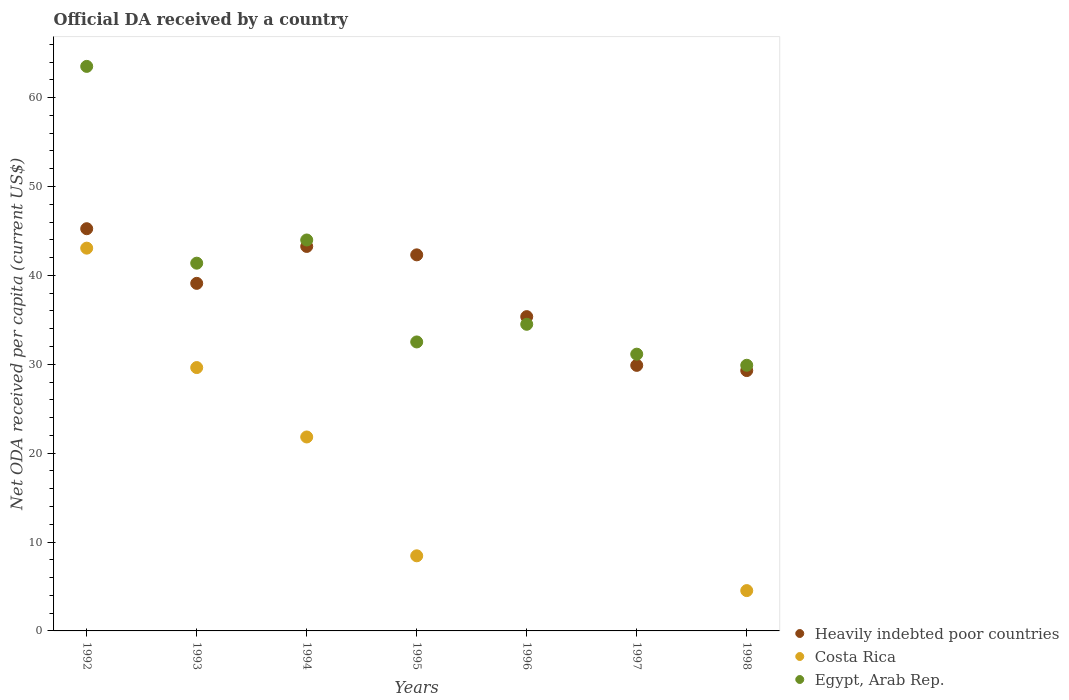Is the number of dotlines equal to the number of legend labels?
Offer a terse response. No. What is the ODA received in in Costa Rica in 1995?
Offer a very short reply. 8.45. Across all years, what is the maximum ODA received in in Heavily indebted poor countries?
Give a very brief answer. 45.25. Across all years, what is the minimum ODA received in in Heavily indebted poor countries?
Keep it short and to the point. 29.29. In which year was the ODA received in in Egypt, Arab Rep. maximum?
Keep it short and to the point. 1992. What is the total ODA received in in Egypt, Arab Rep. in the graph?
Your answer should be compact. 276.91. What is the difference between the ODA received in in Heavily indebted poor countries in 1993 and that in 1998?
Offer a terse response. 9.81. What is the difference between the ODA received in in Egypt, Arab Rep. in 1998 and the ODA received in in Costa Rica in 1995?
Ensure brevity in your answer.  21.44. What is the average ODA received in in Costa Rica per year?
Your response must be concise. 15.36. In the year 1998, what is the difference between the ODA received in in Costa Rica and ODA received in in Egypt, Arab Rep.?
Make the answer very short. -25.35. What is the ratio of the ODA received in in Egypt, Arab Rep. in 1992 to that in 1995?
Give a very brief answer. 1.95. Is the difference between the ODA received in in Costa Rica in 1994 and 1995 greater than the difference between the ODA received in in Egypt, Arab Rep. in 1994 and 1995?
Provide a succinct answer. Yes. What is the difference between the highest and the second highest ODA received in in Egypt, Arab Rep.?
Keep it short and to the point. 19.53. What is the difference between the highest and the lowest ODA received in in Costa Rica?
Give a very brief answer. 43.06. Is the sum of the ODA received in in Egypt, Arab Rep. in 1994 and 1996 greater than the maximum ODA received in in Heavily indebted poor countries across all years?
Keep it short and to the point. Yes. Does the ODA received in in Costa Rica monotonically increase over the years?
Make the answer very short. No. Is the ODA received in in Heavily indebted poor countries strictly less than the ODA received in in Egypt, Arab Rep. over the years?
Your response must be concise. No. How many dotlines are there?
Offer a very short reply. 3. How many years are there in the graph?
Offer a very short reply. 7. What is the difference between two consecutive major ticks on the Y-axis?
Offer a terse response. 10. Are the values on the major ticks of Y-axis written in scientific E-notation?
Offer a terse response. No. Does the graph contain grids?
Your answer should be compact. No. How are the legend labels stacked?
Ensure brevity in your answer.  Vertical. What is the title of the graph?
Your response must be concise. Official DA received by a country. What is the label or title of the X-axis?
Offer a very short reply. Years. What is the label or title of the Y-axis?
Ensure brevity in your answer.  Net ODA received per capita (current US$). What is the Net ODA received per capita (current US$) of Heavily indebted poor countries in 1992?
Your answer should be compact. 45.25. What is the Net ODA received per capita (current US$) in Costa Rica in 1992?
Offer a terse response. 43.06. What is the Net ODA received per capita (current US$) in Egypt, Arab Rep. in 1992?
Make the answer very short. 63.51. What is the Net ODA received per capita (current US$) of Heavily indebted poor countries in 1993?
Your answer should be compact. 39.1. What is the Net ODA received per capita (current US$) in Costa Rica in 1993?
Ensure brevity in your answer.  29.63. What is the Net ODA received per capita (current US$) of Egypt, Arab Rep. in 1993?
Your response must be concise. 41.37. What is the Net ODA received per capita (current US$) in Heavily indebted poor countries in 1994?
Offer a terse response. 43.26. What is the Net ODA received per capita (current US$) in Costa Rica in 1994?
Your answer should be compact. 21.82. What is the Net ODA received per capita (current US$) of Egypt, Arab Rep. in 1994?
Your answer should be very brief. 43.98. What is the Net ODA received per capita (current US$) in Heavily indebted poor countries in 1995?
Give a very brief answer. 42.31. What is the Net ODA received per capita (current US$) of Costa Rica in 1995?
Your response must be concise. 8.45. What is the Net ODA received per capita (current US$) of Egypt, Arab Rep. in 1995?
Provide a short and direct response. 32.51. What is the Net ODA received per capita (current US$) of Heavily indebted poor countries in 1996?
Provide a short and direct response. 35.36. What is the Net ODA received per capita (current US$) of Costa Rica in 1996?
Provide a short and direct response. 0. What is the Net ODA received per capita (current US$) in Egypt, Arab Rep. in 1996?
Provide a succinct answer. 34.5. What is the Net ODA received per capita (current US$) of Heavily indebted poor countries in 1997?
Keep it short and to the point. 29.88. What is the Net ODA received per capita (current US$) of Egypt, Arab Rep. in 1997?
Your answer should be very brief. 31.14. What is the Net ODA received per capita (current US$) in Heavily indebted poor countries in 1998?
Provide a succinct answer. 29.29. What is the Net ODA received per capita (current US$) in Costa Rica in 1998?
Give a very brief answer. 4.54. What is the Net ODA received per capita (current US$) of Egypt, Arab Rep. in 1998?
Provide a succinct answer. 29.89. Across all years, what is the maximum Net ODA received per capita (current US$) in Heavily indebted poor countries?
Keep it short and to the point. 45.25. Across all years, what is the maximum Net ODA received per capita (current US$) of Costa Rica?
Offer a terse response. 43.06. Across all years, what is the maximum Net ODA received per capita (current US$) in Egypt, Arab Rep.?
Give a very brief answer. 63.51. Across all years, what is the minimum Net ODA received per capita (current US$) of Heavily indebted poor countries?
Keep it short and to the point. 29.29. Across all years, what is the minimum Net ODA received per capita (current US$) of Egypt, Arab Rep.?
Provide a short and direct response. 29.89. What is the total Net ODA received per capita (current US$) of Heavily indebted poor countries in the graph?
Keep it short and to the point. 264.45. What is the total Net ODA received per capita (current US$) of Costa Rica in the graph?
Your answer should be compact. 107.5. What is the total Net ODA received per capita (current US$) of Egypt, Arab Rep. in the graph?
Offer a terse response. 276.91. What is the difference between the Net ODA received per capita (current US$) in Heavily indebted poor countries in 1992 and that in 1993?
Your response must be concise. 6.15. What is the difference between the Net ODA received per capita (current US$) of Costa Rica in 1992 and that in 1993?
Give a very brief answer. 13.44. What is the difference between the Net ODA received per capita (current US$) in Egypt, Arab Rep. in 1992 and that in 1993?
Your response must be concise. 22.14. What is the difference between the Net ODA received per capita (current US$) in Heavily indebted poor countries in 1992 and that in 1994?
Make the answer very short. 1.99. What is the difference between the Net ODA received per capita (current US$) of Costa Rica in 1992 and that in 1994?
Your response must be concise. 21.24. What is the difference between the Net ODA received per capita (current US$) in Egypt, Arab Rep. in 1992 and that in 1994?
Offer a terse response. 19.53. What is the difference between the Net ODA received per capita (current US$) of Heavily indebted poor countries in 1992 and that in 1995?
Your response must be concise. 2.94. What is the difference between the Net ODA received per capita (current US$) of Costa Rica in 1992 and that in 1995?
Ensure brevity in your answer.  34.61. What is the difference between the Net ODA received per capita (current US$) of Egypt, Arab Rep. in 1992 and that in 1995?
Your response must be concise. 31. What is the difference between the Net ODA received per capita (current US$) in Heavily indebted poor countries in 1992 and that in 1996?
Make the answer very short. 9.89. What is the difference between the Net ODA received per capita (current US$) of Egypt, Arab Rep. in 1992 and that in 1996?
Offer a very short reply. 29.02. What is the difference between the Net ODA received per capita (current US$) of Heavily indebted poor countries in 1992 and that in 1997?
Give a very brief answer. 15.38. What is the difference between the Net ODA received per capita (current US$) of Egypt, Arab Rep. in 1992 and that in 1997?
Provide a short and direct response. 32.38. What is the difference between the Net ODA received per capita (current US$) in Heavily indebted poor countries in 1992 and that in 1998?
Give a very brief answer. 15.96. What is the difference between the Net ODA received per capita (current US$) of Costa Rica in 1992 and that in 1998?
Make the answer very short. 38.53. What is the difference between the Net ODA received per capita (current US$) of Egypt, Arab Rep. in 1992 and that in 1998?
Give a very brief answer. 33.63. What is the difference between the Net ODA received per capita (current US$) of Heavily indebted poor countries in 1993 and that in 1994?
Ensure brevity in your answer.  -4.15. What is the difference between the Net ODA received per capita (current US$) of Costa Rica in 1993 and that in 1994?
Give a very brief answer. 7.81. What is the difference between the Net ODA received per capita (current US$) in Egypt, Arab Rep. in 1993 and that in 1994?
Provide a succinct answer. -2.61. What is the difference between the Net ODA received per capita (current US$) in Heavily indebted poor countries in 1993 and that in 1995?
Offer a terse response. -3.21. What is the difference between the Net ODA received per capita (current US$) in Costa Rica in 1993 and that in 1995?
Keep it short and to the point. 21.18. What is the difference between the Net ODA received per capita (current US$) in Egypt, Arab Rep. in 1993 and that in 1995?
Provide a short and direct response. 8.86. What is the difference between the Net ODA received per capita (current US$) in Heavily indebted poor countries in 1993 and that in 1996?
Make the answer very short. 3.74. What is the difference between the Net ODA received per capita (current US$) of Egypt, Arab Rep. in 1993 and that in 1996?
Offer a terse response. 6.88. What is the difference between the Net ODA received per capita (current US$) in Heavily indebted poor countries in 1993 and that in 1997?
Your answer should be very brief. 9.23. What is the difference between the Net ODA received per capita (current US$) of Egypt, Arab Rep. in 1993 and that in 1997?
Give a very brief answer. 10.24. What is the difference between the Net ODA received per capita (current US$) in Heavily indebted poor countries in 1993 and that in 1998?
Ensure brevity in your answer.  9.81. What is the difference between the Net ODA received per capita (current US$) in Costa Rica in 1993 and that in 1998?
Ensure brevity in your answer.  25.09. What is the difference between the Net ODA received per capita (current US$) of Egypt, Arab Rep. in 1993 and that in 1998?
Your response must be concise. 11.49. What is the difference between the Net ODA received per capita (current US$) of Heavily indebted poor countries in 1994 and that in 1995?
Make the answer very short. 0.95. What is the difference between the Net ODA received per capita (current US$) in Costa Rica in 1994 and that in 1995?
Offer a terse response. 13.37. What is the difference between the Net ODA received per capita (current US$) of Egypt, Arab Rep. in 1994 and that in 1995?
Provide a short and direct response. 11.47. What is the difference between the Net ODA received per capita (current US$) of Heavily indebted poor countries in 1994 and that in 1996?
Make the answer very short. 7.9. What is the difference between the Net ODA received per capita (current US$) of Egypt, Arab Rep. in 1994 and that in 1996?
Give a very brief answer. 9.48. What is the difference between the Net ODA received per capita (current US$) of Heavily indebted poor countries in 1994 and that in 1997?
Give a very brief answer. 13.38. What is the difference between the Net ODA received per capita (current US$) in Egypt, Arab Rep. in 1994 and that in 1997?
Your response must be concise. 12.84. What is the difference between the Net ODA received per capita (current US$) of Heavily indebted poor countries in 1994 and that in 1998?
Offer a very short reply. 13.97. What is the difference between the Net ODA received per capita (current US$) of Costa Rica in 1994 and that in 1998?
Your answer should be very brief. 17.28. What is the difference between the Net ODA received per capita (current US$) in Egypt, Arab Rep. in 1994 and that in 1998?
Your answer should be compact. 14.09. What is the difference between the Net ODA received per capita (current US$) of Heavily indebted poor countries in 1995 and that in 1996?
Ensure brevity in your answer.  6.95. What is the difference between the Net ODA received per capita (current US$) of Egypt, Arab Rep. in 1995 and that in 1996?
Your response must be concise. -1.99. What is the difference between the Net ODA received per capita (current US$) of Heavily indebted poor countries in 1995 and that in 1997?
Make the answer very short. 12.44. What is the difference between the Net ODA received per capita (current US$) in Egypt, Arab Rep. in 1995 and that in 1997?
Your answer should be compact. 1.37. What is the difference between the Net ODA received per capita (current US$) of Heavily indebted poor countries in 1995 and that in 1998?
Give a very brief answer. 13.02. What is the difference between the Net ODA received per capita (current US$) of Costa Rica in 1995 and that in 1998?
Offer a terse response. 3.91. What is the difference between the Net ODA received per capita (current US$) of Egypt, Arab Rep. in 1995 and that in 1998?
Provide a succinct answer. 2.62. What is the difference between the Net ODA received per capita (current US$) of Heavily indebted poor countries in 1996 and that in 1997?
Make the answer very short. 5.48. What is the difference between the Net ODA received per capita (current US$) in Egypt, Arab Rep. in 1996 and that in 1997?
Your answer should be compact. 3.36. What is the difference between the Net ODA received per capita (current US$) of Heavily indebted poor countries in 1996 and that in 1998?
Ensure brevity in your answer.  6.07. What is the difference between the Net ODA received per capita (current US$) of Egypt, Arab Rep. in 1996 and that in 1998?
Make the answer very short. 4.61. What is the difference between the Net ODA received per capita (current US$) in Heavily indebted poor countries in 1997 and that in 1998?
Make the answer very short. 0.58. What is the difference between the Net ODA received per capita (current US$) in Egypt, Arab Rep. in 1997 and that in 1998?
Make the answer very short. 1.25. What is the difference between the Net ODA received per capita (current US$) in Heavily indebted poor countries in 1992 and the Net ODA received per capita (current US$) in Costa Rica in 1993?
Make the answer very short. 15.62. What is the difference between the Net ODA received per capita (current US$) of Heavily indebted poor countries in 1992 and the Net ODA received per capita (current US$) of Egypt, Arab Rep. in 1993?
Give a very brief answer. 3.88. What is the difference between the Net ODA received per capita (current US$) of Costa Rica in 1992 and the Net ODA received per capita (current US$) of Egypt, Arab Rep. in 1993?
Provide a short and direct response. 1.69. What is the difference between the Net ODA received per capita (current US$) in Heavily indebted poor countries in 1992 and the Net ODA received per capita (current US$) in Costa Rica in 1994?
Ensure brevity in your answer.  23.43. What is the difference between the Net ODA received per capita (current US$) in Heavily indebted poor countries in 1992 and the Net ODA received per capita (current US$) in Egypt, Arab Rep. in 1994?
Provide a short and direct response. 1.27. What is the difference between the Net ODA received per capita (current US$) in Costa Rica in 1992 and the Net ODA received per capita (current US$) in Egypt, Arab Rep. in 1994?
Provide a short and direct response. -0.92. What is the difference between the Net ODA received per capita (current US$) of Heavily indebted poor countries in 1992 and the Net ODA received per capita (current US$) of Costa Rica in 1995?
Your answer should be very brief. 36.8. What is the difference between the Net ODA received per capita (current US$) of Heavily indebted poor countries in 1992 and the Net ODA received per capita (current US$) of Egypt, Arab Rep. in 1995?
Give a very brief answer. 12.74. What is the difference between the Net ODA received per capita (current US$) of Costa Rica in 1992 and the Net ODA received per capita (current US$) of Egypt, Arab Rep. in 1995?
Provide a succinct answer. 10.55. What is the difference between the Net ODA received per capita (current US$) of Heavily indebted poor countries in 1992 and the Net ODA received per capita (current US$) of Egypt, Arab Rep. in 1996?
Your response must be concise. 10.75. What is the difference between the Net ODA received per capita (current US$) in Costa Rica in 1992 and the Net ODA received per capita (current US$) in Egypt, Arab Rep. in 1996?
Keep it short and to the point. 8.57. What is the difference between the Net ODA received per capita (current US$) of Heavily indebted poor countries in 1992 and the Net ODA received per capita (current US$) of Egypt, Arab Rep. in 1997?
Give a very brief answer. 14.11. What is the difference between the Net ODA received per capita (current US$) of Costa Rica in 1992 and the Net ODA received per capita (current US$) of Egypt, Arab Rep. in 1997?
Your response must be concise. 11.93. What is the difference between the Net ODA received per capita (current US$) in Heavily indebted poor countries in 1992 and the Net ODA received per capita (current US$) in Costa Rica in 1998?
Keep it short and to the point. 40.72. What is the difference between the Net ODA received per capita (current US$) in Heavily indebted poor countries in 1992 and the Net ODA received per capita (current US$) in Egypt, Arab Rep. in 1998?
Offer a very short reply. 15.36. What is the difference between the Net ODA received per capita (current US$) in Costa Rica in 1992 and the Net ODA received per capita (current US$) in Egypt, Arab Rep. in 1998?
Keep it short and to the point. 13.18. What is the difference between the Net ODA received per capita (current US$) in Heavily indebted poor countries in 1993 and the Net ODA received per capita (current US$) in Costa Rica in 1994?
Provide a short and direct response. 17.28. What is the difference between the Net ODA received per capita (current US$) of Heavily indebted poor countries in 1993 and the Net ODA received per capita (current US$) of Egypt, Arab Rep. in 1994?
Your answer should be compact. -4.88. What is the difference between the Net ODA received per capita (current US$) of Costa Rica in 1993 and the Net ODA received per capita (current US$) of Egypt, Arab Rep. in 1994?
Your answer should be very brief. -14.35. What is the difference between the Net ODA received per capita (current US$) of Heavily indebted poor countries in 1993 and the Net ODA received per capita (current US$) of Costa Rica in 1995?
Give a very brief answer. 30.65. What is the difference between the Net ODA received per capita (current US$) of Heavily indebted poor countries in 1993 and the Net ODA received per capita (current US$) of Egypt, Arab Rep. in 1995?
Provide a succinct answer. 6.59. What is the difference between the Net ODA received per capita (current US$) in Costa Rica in 1993 and the Net ODA received per capita (current US$) in Egypt, Arab Rep. in 1995?
Your answer should be compact. -2.88. What is the difference between the Net ODA received per capita (current US$) of Heavily indebted poor countries in 1993 and the Net ODA received per capita (current US$) of Egypt, Arab Rep. in 1996?
Provide a short and direct response. 4.61. What is the difference between the Net ODA received per capita (current US$) in Costa Rica in 1993 and the Net ODA received per capita (current US$) in Egypt, Arab Rep. in 1996?
Provide a succinct answer. -4.87. What is the difference between the Net ODA received per capita (current US$) in Heavily indebted poor countries in 1993 and the Net ODA received per capita (current US$) in Egypt, Arab Rep. in 1997?
Keep it short and to the point. 7.97. What is the difference between the Net ODA received per capita (current US$) of Costa Rica in 1993 and the Net ODA received per capita (current US$) of Egypt, Arab Rep. in 1997?
Offer a terse response. -1.51. What is the difference between the Net ODA received per capita (current US$) in Heavily indebted poor countries in 1993 and the Net ODA received per capita (current US$) in Costa Rica in 1998?
Provide a short and direct response. 34.57. What is the difference between the Net ODA received per capita (current US$) of Heavily indebted poor countries in 1993 and the Net ODA received per capita (current US$) of Egypt, Arab Rep. in 1998?
Offer a very short reply. 9.22. What is the difference between the Net ODA received per capita (current US$) in Costa Rica in 1993 and the Net ODA received per capita (current US$) in Egypt, Arab Rep. in 1998?
Keep it short and to the point. -0.26. What is the difference between the Net ODA received per capita (current US$) of Heavily indebted poor countries in 1994 and the Net ODA received per capita (current US$) of Costa Rica in 1995?
Provide a short and direct response. 34.81. What is the difference between the Net ODA received per capita (current US$) of Heavily indebted poor countries in 1994 and the Net ODA received per capita (current US$) of Egypt, Arab Rep. in 1995?
Ensure brevity in your answer.  10.75. What is the difference between the Net ODA received per capita (current US$) of Costa Rica in 1994 and the Net ODA received per capita (current US$) of Egypt, Arab Rep. in 1995?
Provide a succinct answer. -10.69. What is the difference between the Net ODA received per capita (current US$) of Heavily indebted poor countries in 1994 and the Net ODA received per capita (current US$) of Egypt, Arab Rep. in 1996?
Offer a very short reply. 8.76. What is the difference between the Net ODA received per capita (current US$) in Costa Rica in 1994 and the Net ODA received per capita (current US$) in Egypt, Arab Rep. in 1996?
Ensure brevity in your answer.  -12.68. What is the difference between the Net ODA received per capita (current US$) in Heavily indebted poor countries in 1994 and the Net ODA received per capita (current US$) in Egypt, Arab Rep. in 1997?
Provide a short and direct response. 12.12. What is the difference between the Net ODA received per capita (current US$) in Costa Rica in 1994 and the Net ODA received per capita (current US$) in Egypt, Arab Rep. in 1997?
Offer a terse response. -9.32. What is the difference between the Net ODA received per capita (current US$) of Heavily indebted poor countries in 1994 and the Net ODA received per capita (current US$) of Costa Rica in 1998?
Give a very brief answer. 38.72. What is the difference between the Net ODA received per capita (current US$) of Heavily indebted poor countries in 1994 and the Net ODA received per capita (current US$) of Egypt, Arab Rep. in 1998?
Provide a succinct answer. 13.37. What is the difference between the Net ODA received per capita (current US$) in Costa Rica in 1994 and the Net ODA received per capita (current US$) in Egypt, Arab Rep. in 1998?
Keep it short and to the point. -8.07. What is the difference between the Net ODA received per capita (current US$) in Heavily indebted poor countries in 1995 and the Net ODA received per capita (current US$) in Egypt, Arab Rep. in 1996?
Offer a very short reply. 7.81. What is the difference between the Net ODA received per capita (current US$) in Costa Rica in 1995 and the Net ODA received per capita (current US$) in Egypt, Arab Rep. in 1996?
Your answer should be compact. -26.05. What is the difference between the Net ODA received per capita (current US$) in Heavily indebted poor countries in 1995 and the Net ODA received per capita (current US$) in Egypt, Arab Rep. in 1997?
Offer a terse response. 11.17. What is the difference between the Net ODA received per capita (current US$) of Costa Rica in 1995 and the Net ODA received per capita (current US$) of Egypt, Arab Rep. in 1997?
Your answer should be compact. -22.69. What is the difference between the Net ODA received per capita (current US$) in Heavily indebted poor countries in 1995 and the Net ODA received per capita (current US$) in Costa Rica in 1998?
Your response must be concise. 37.78. What is the difference between the Net ODA received per capita (current US$) of Heavily indebted poor countries in 1995 and the Net ODA received per capita (current US$) of Egypt, Arab Rep. in 1998?
Keep it short and to the point. 12.42. What is the difference between the Net ODA received per capita (current US$) in Costa Rica in 1995 and the Net ODA received per capita (current US$) in Egypt, Arab Rep. in 1998?
Your answer should be compact. -21.44. What is the difference between the Net ODA received per capita (current US$) in Heavily indebted poor countries in 1996 and the Net ODA received per capita (current US$) in Egypt, Arab Rep. in 1997?
Your answer should be compact. 4.22. What is the difference between the Net ODA received per capita (current US$) of Heavily indebted poor countries in 1996 and the Net ODA received per capita (current US$) of Costa Rica in 1998?
Offer a terse response. 30.82. What is the difference between the Net ODA received per capita (current US$) in Heavily indebted poor countries in 1996 and the Net ODA received per capita (current US$) in Egypt, Arab Rep. in 1998?
Give a very brief answer. 5.47. What is the difference between the Net ODA received per capita (current US$) of Heavily indebted poor countries in 1997 and the Net ODA received per capita (current US$) of Costa Rica in 1998?
Your answer should be very brief. 25.34. What is the difference between the Net ODA received per capita (current US$) of Heavily indebted poor countries in 1997 and the Net ODA received per capita (current US$) of Egypt, Arab Rep. in 1998?
Your response must be concise. -0.01. What is the average Net ODA received per capita (current US$) in Heavily indebted poor countries per year?
Give a very brief answer. 37.78. What is the average Net ODA received per capita (current US$) of Costa Rica per year?
Offer a terse response. 15.36. What is the average Net ODA received per capita (current US$) of Egypt, Arab Rep. per year?
Keep it short and to the point. 39.56. In the year 1992, what is the difference between the Net ODA received per capita (current US$) of Heavily indebted poor countries and Net ODA received per capita (current US$) of Costa Rica?
Provide a succinct answer. 2.19. In the year 1992, what is the difference between the Net ODA received per capita (current US$) of Heavily indebted poor countries and Net ODA received per capita (current US$) of Egypt, Arab Rep.?
Make the answer very short. -18.26. In the year 1992, what is the difference between the Net ODA received per capita (current US$) of Costa Rica and Net ODA received per capita (current US$) of Egypt, Arab Rep.?
Make the answer very short. -20.45. In the year 1993, what is the difference between the Net ODA received per capita (current US$) in Heavily indebted poor countries and Net ODA received per capita (current US$) in Costa Rica?
Offer a very short reply. 9.48. In the year 1993, what is the difference between the Net ODA received per capita (current US$) in Heavily indebted poor countries and Net ODA received per capita (current US$) in Egypt, Arab Rep.?
Offer a terse response. -2.27. In the year 1993, what is the difference between the Net ODA received per capita (current US$) in Costa Rica and Net ODA received per capita (current US$) in Egypt, Arab Rep.?
Your answer should be very brief. -11.75. In the year 1994, what is the difference between the Net ODA received per capita (current US$) in Heavily indebted poor countries and Net ODA received per capita (current US$) in Costa Rica?
Offer a very short reply. 21.44. In the year 1994, what is the difference between the Net ODA received per capita (current US$) in Heavily indebted poor countries and Net ODA received per capita (current US$) in Egypt, Arab Rep.?
Your response must be concise. -0.72. In the year 1994, what is the difference between the Net ODA received per capita (current US$) in Costa Rica and Net ODA received per capita (current US$) in Egypt, Arab Rep.?
Keep it short and to the point. -22.16. In the year 1995, what is the difference between the Net ODA received per capita (current US$) in Heavily indebted poor countries and Net ODA received per capita (current US$) in Costa Rica?
Keep it short and to the point. 33.86. In the year 1995, what is the difference between the Net ODA received per capita (current US$) in Heavily indebted poor countries and Net ODA received per capita (current US$) in Egypt, Arab Rep.?
Provide a succinct answer. 9.8. In the year 1995, what is the difference between the Net ODA received per capita (current US$) in Costa Rica and Net ODA received per capita (current US$) in Egypt, Arab Rep.?
Offer a very short reply. -24.06. In the year 1996, what is the difference between the Net ODA received per capita (current US$) of Heavily indebted poor countries and Net ODA received per capita (current US$) of Egypt, Arab Rep.?
Your answer should be compact. 0.86. In the year 1997, what is the difference between the Net ODA received per capita (current US$) of Heavily indebted poor countries and Net ODA received per capita (current US$) of Egypt, Arab Rep.?
Your response must be concise. -1.26. In the year 1998, what is the difference between the Net ODA received per capita (current US$) in Heavily indebted poor countries and Net ODA received per capita (current US$) in Costa Rica?
Give a very brief answer. 24.76. In the year 1998, what is the difference between the Net ODA received per capita (current US$) of Heavily indebted poor countries and Net ODA received per capita (current US$) of Egypt, Arab Rep.?
Your response must be concise. -0.6. In the year 1998, what is the difference between the Net ODA received per capita (current US$) in Costa Rica and Net ODA received per capita (current US$) in Egypt, Arab Rep.?
Provide a short and direct response. -25.35. What is the ratio of the Net ODA received per capita (current US$) in Heavily indebted poor countries in 1992 to that in 1993?
Make the answer very short. 1.16. What is the ratio of the Net ODA received per capita (current US$) of Costa Rica in 1992 to that in 1993?
Make the answer very short. 1.45. What is the ratio of the Net ODA received per capita (current US$) of Egypt, Arab Rep. in 1992 to that in 1993?
Offer a very short reply. 1.54. What is the ratio of the Net ODA received per capita (current US$) in Heavily indebted poor countries in 1992 to that in 1994?
Provide a short and direct response. 1.05. What is the ratio of the Net ODA received per capita (current US$) of Costa Rica in 1992 to that in 1994?
Provide a succinct answer. 1.97. What is the ratio of the Net ODA received per capita (current US$) of Egypt, Arab Rep. in 1992 to that in 1994?
Your response must be concise. 1.44. What is the ratio of the Net ODA received per capita (current US$) of Heavily indebted poor countries in 1992 to that in 1995?
Offer a very short reply. 1.07. What is the ratio of the Net ODA received per capita (current US$) of Costa Rica in 1992 to that in 1995?
Give a very brief answer. 5.1. What is the ratio of the Net ODA received per capita (current US$) in Egypt, Arab Rep. in 1992 to that in 1995?
Keep it short and to the point. 1.95. What is the ratio of the Net ODA received per capita (current US$) of Heavily indebted poor countries in 1992 to that in 1996?
Ensure brevity in your answer.  1.28. What is the ratio of the Net ODA received per capita (current US$) in Egypt, Arab Rep. in 1992 to that in 1996?
Give a very brief answer. 1.84. What is the ratio of the Net ODA received per capita (current US$) in Heavily indebted poor countries in 1992 to that in 1997?
Offer a very short reply. 1.51. What is the ratio of the Net ODA received per capita (current US$) of Egypt, Arab Rep. in 1992 to that in 1997?
Provide a short and direct response. 2.04. What is the ratio of the Net ODA received per capita (current US$) of Heavily indebted poor countries in 1992 to that in 1998?
Your answer should be very brief. 1.54. What is the ratio of the Net ODA received per capita (current US$) of Costa Rica in 1992 to that in 1998?
Your answer should be compact. 9.49. What is the ratio of the Net ODA received per capita (current US$) of Egypt, Arab Rep. in 1992 to that in 1998?
Ensure brevity in your answer.  2.13. What is the ratio of the Net ODA received per capita (current US$) in Heavily indebted poor countries in 1993 to that in 1994?
Offer a terse response. 0.9. What is the ratio of the Net ODA received per capita (current US$) of Costa Rica in 1993 to that in 1994?
Provide a short and direct response. 1.36. What is the ratio of the Net ODA received per capita (current US$) of Egypt, Arab Rep. in 1993 to that in 1994?
Your answer should be compact. 0.94. What is the ratio of the Net ODA received per capita (current US$) in Heavily indebted poor countries in 1993 to that in 1995?
Your answer should be very brief. 0.92. What is the ratio of the Net ODA received per capita (current US$) in Costa Rica in 1993 to that in 1995?
Give a very brief answer. 3.51. What is the ratio of the Net ODA received per capita (current US$) in Egypt, Arab Rep. in 1993 to that in 1995?
Provide a short and direct response. 1.27. What is the ratio of the Net ODA received per capita (current US$) in Heavily indebted poor countries in 1993 to that in 1996?
Give a very brief answer. 1.11. What is the ratio of the Net ODA received per capita (current US$) of Egypt, Arab Rep. in 1993 to that in 1996?
Ensure brevity in your answer.  1.2. What is the ratio of the Net ODA received per capita (current US$) in Heavily indebted poor countries in 1993 to that in 1997?
Keep it short and to the point. 1.31. What is the ratio of the Net ODA received per capita (current US$) of Egypt, Arab Rep. in 1993 to that in 1997?
Make the answer very short. 1.33. What is the ratio of the Net ODA received per capita (current US$) of Heavily indebted poor countries in 1993 to that in 1998?
Your response must be concise. 1.33. What is the ratio of the Net ODA received per capita (current US$) of Costa Rica in 1993 to that in 1998?
Keep it short and to the point. 6.53. What is the ratio of the Net ODA received per capita (current US$) of Egypt, Arab Rep. in 1993 to that in 1998?
Keep it short and to the point. 1.38. What is the ratio of the Net ODA received per capita (current US$) in Heavily indebted poor countries in 1994 to that in 1995?
Your answer should be compact. 1.02. What is the ratio of the Net ODA received per capita (current US$) of Costa Rica in 1994 to that in 1995?
Keep it short and to the point. 2.58. What is the ratio of the Net ODA received per capita (current US$) in Egypt, Arab Rep. in 1994 to that in 1995?
Offer a terse response. 1.35. What is the ratio of the Net ODA received per capita (current US$) of Heavily indebted poor countries in 1994 to that in 1996?
Ensure brevity in your answer.  1.22. What is the ratio of the Net ODA received per capita (current US$) in Egypt, Arab Rep. in 1994 to that in 1996?
Your response must be concise. 1.27. What is the ratio of the Net ODA received per capita (current US$) in Heavily indebted poor countries in 1994 to that in 1997?
Make the answer very short. 1.45. What is the ratio of the Net ODA received per capita (current US$) of Egypt, Arab Rep. in 1994 to that in 1997?
Give a very brief answer. 1.41. What is the ratio of the Net ODA received per capita (current US$) of Heavily indebted poor countries in 1994 to that in 1998?
Give a very brief answer. 1.48. What is the ratio of the Net ODA received per capita (current US$) in Costa Rica in 1994 to that in 1998?
Give a very brief answer. 4.81. What is the ratio of the Net ODA received per capita (current US$) of Egypt, Arab Rep. in 1994 to that in 1998?
Provide a short and direct response. 1.47. What is the ratio of the Net ODA received per capita (current US$) of Heavily indebted poor countries in 1995 to that in 1996?
Ensure brevity in your answer.  1.2. What is the ratio of the Net ODA received per capita (current US$) in Egypt, Arab Rep. in 1995 to that in 1996?
Ensure brevity in your answer.  0.94. What is the ratio of the Net ODA received per capita (current US$) of Heavily indebted poor countries in 1995 to that in 1997?
Your answer should be very brief. 1.42. What is the ratio of the Net ODA received per capita (current US$) in Egypt, Arab Rep. in 1995 to that in 1997?
Ensure brevity in your answer.  1.04. What is the ratio of the Net ODA received per capita (current US$) of Heavily indebted poor countries in 1995 to that in 1998?
Your answer should be compact. 1.44. What is the ratio of the Net ODA received per capita (current US$) in Costa Rica in 1995 to that in 1998?
Offer a terse response. 1.86. What is the ratio of the Net ODA received per capita (current US$) of Egypt, Arab Rep. in 1995 to that in 1998?
Keep it short and to the point. 1.09. What is the ratio of the Net ODA received per capita (current US$) in Heavily indebted poor countries in 1996 to that in 1997?
Your response must be concise. 1.18. What is the ratio of the Net ODA received per capita (current US$) of Egypt, Arab Rep. in 1996 to that in 1997?
Your answer should be very brief. 1.11. What is the ratio of the Net ODA received per capita (current US$) in Heavily indebted poor countries in 1996 to that in 1998?
Offer a very short reply. 1.21. What is the ratio of the Net ODA received per capita (current US$) in Egypt, Arab Rep. in 1996 to that in 1998?
Your answer should be very brief. 1.15. What is the ratio of the Net ODA received per capita (current US$) in Egypt, Arab Rep. in 1997 to that in 1998?
Provide a short and direct response. 1.04. What is the difference between the highest and the second highest Net ODA received per capita (current US$) of Heavily indebted poor countries?
Keep it short and to the point. 1.99. What is the difference between the highest and the second highest Net ODA received per capita (current US$) of Costa Rica?
Provide a short and direct response. 13.44. What is the difference between the highest and the second highest Net ODA received per capita (current US$) in Egypt, Arab Rep.?
Your response must be concise. 19.53. What is the difference between the highest and the lowest Net ODA received per capita (current US$) in Heavily indebted poor countries?
Make the answer very short. 15.96. What is the difference between the highest and the lowest Net ODA received per capita (current US$) in Costa Rica?
Offer a terse response. 43.06. What is the difference between the highest and the lowest Net ODA received per capita (current US$) in Egypt, Arab Rep.?
Offer a terse response. 33.63. 